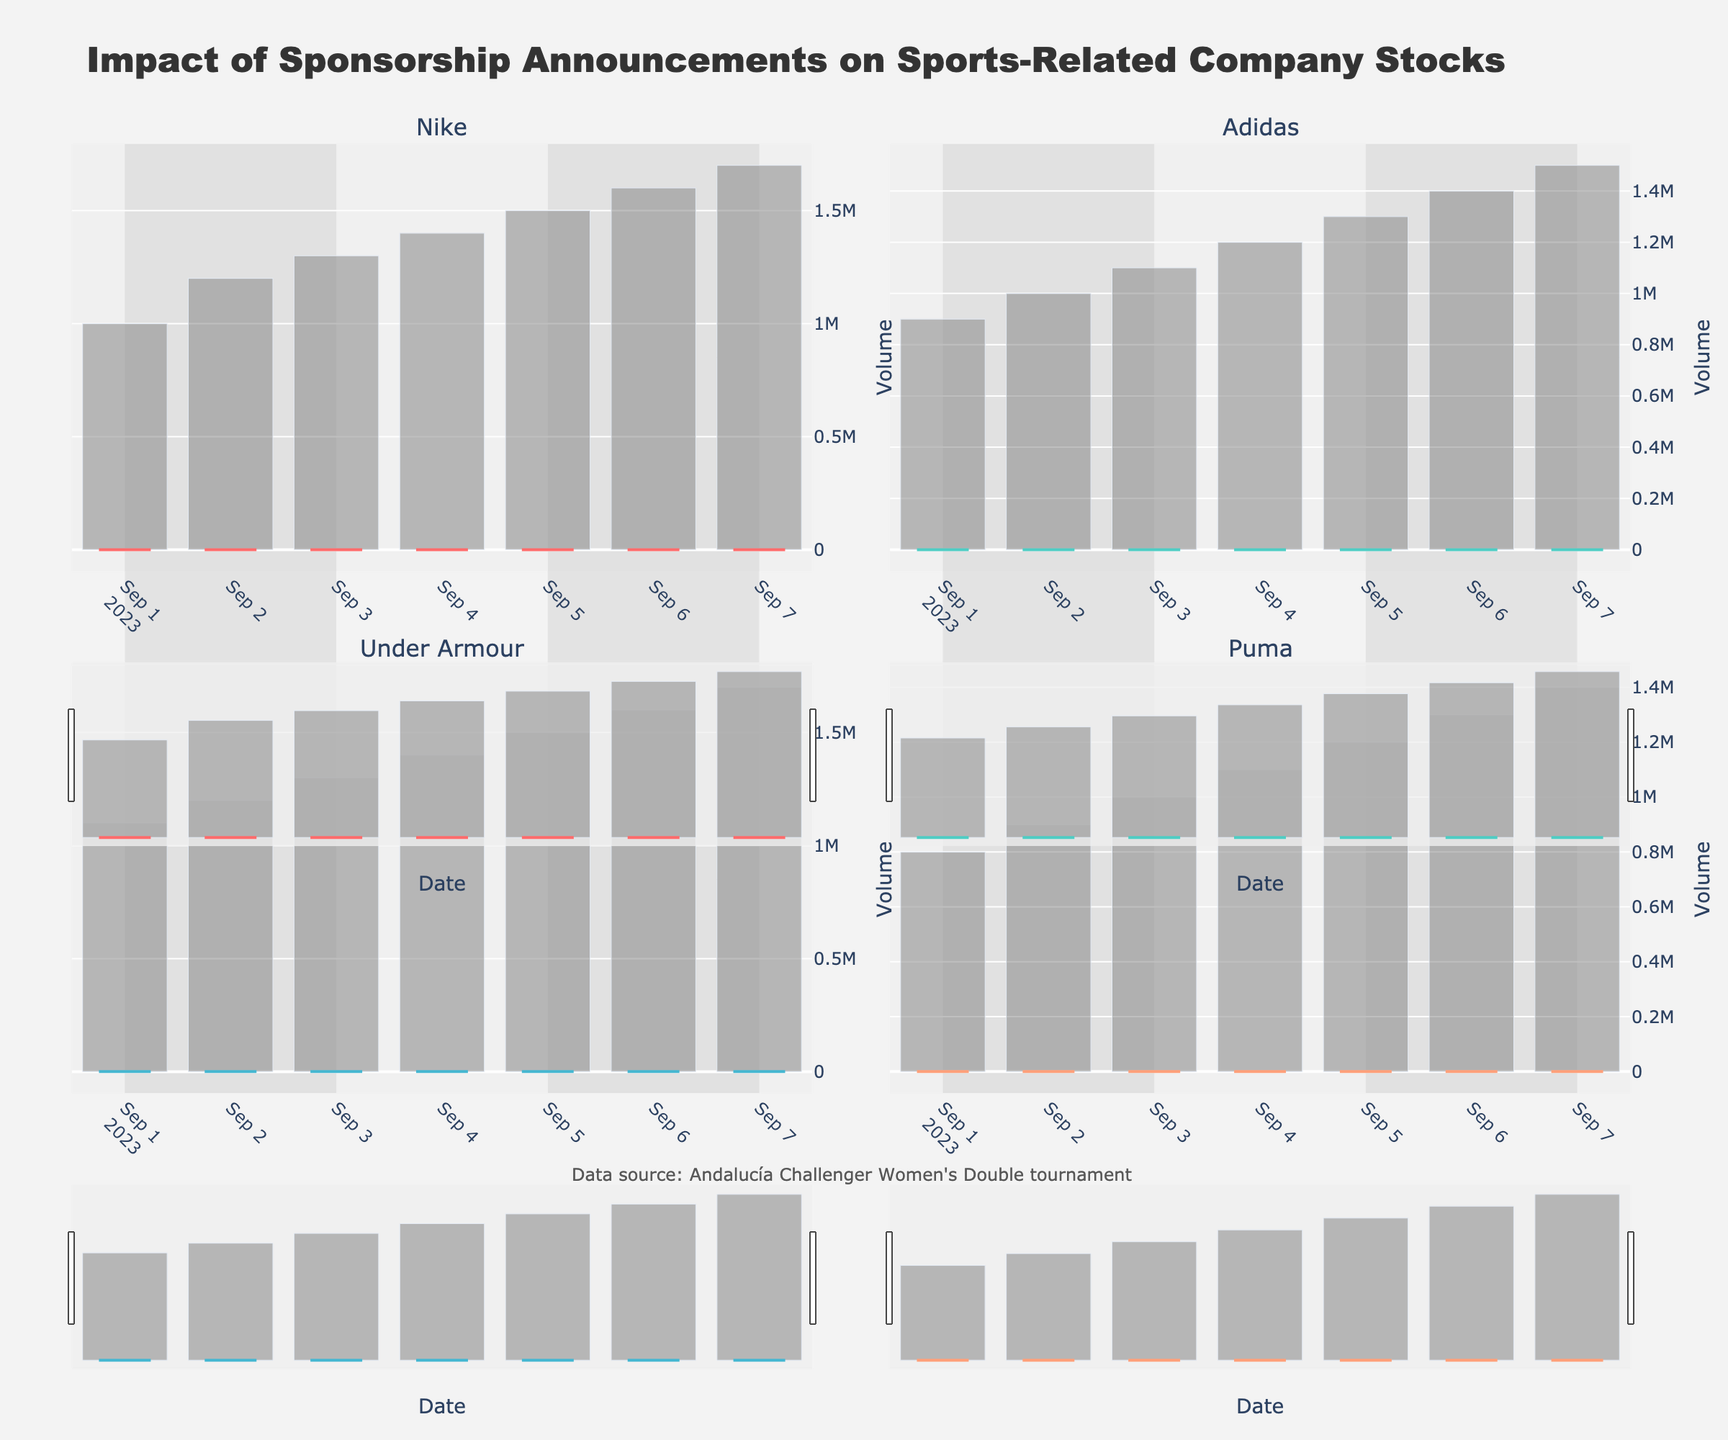Which company showed the largest increase in their stock price from the first day to the last day? For each company, subtract the opening price on September 1st from the closing price on September 7th. Nike: 161.00 - 150.00 = 11.00, Adidas: 114.00 - 100.00 = 14.00, Under Armour: 215.00 - 200.00 = 15.00, Puma: 63.50 - 50.00 = 13.50. The largest increase is for Under Armour, with an increase of 15.00.
Answer: Under Armour What was the stock price range (difference between high and low) for Nike on September 6th? Look at the high and low prices for Nike on September 6th. The high was 160.00 and the low was 157.00. Subtract the low price from the high price: 160.00 - 157.00 = 3.00.
Answer: 3.00 How did the volume change for Adidas from the day before the official sponsorship announcement to the day of the announcement? Compare the volume on September 3rd and September 4th for Adidas. On September 3rd, the volume was 1,100,000, and on September 4th, it was 1,200,000. Subtract the volume on September 3rd from the volume on September 4th: 1,200,000 - 1,100,000 = 100,000.
Answer: Increased by 100,000 Which company had the highest closing price on the day of the official sponsorship announcement? Look at the closing prices on September 4th for all companies. Nike: 155.50, Adidas: 106.50, Under Armour: 208.50, Puma: 56.50. The highest closing price was for Under Armour, at 208.50.
Answer: Under Armour What was the percentage increase in Nike's volume from the first day to the last day? Compare the volume on September 1st and September 7th for Nike. Volume on September 1st: 1,000,000; Volume on September 7th: 1,700,000. Calculate the percentage increase: ((1,700,000 - 1,000,000) / 1,000,000) * 100 = 70%.
Answer: 70% Considering the candlestick colors, did Puma's stock close higher or lower than it opened on September 5th? Look for the candlestick color for Puma on September 5th. It is a light color, indicating an increase. The opening price was 56.50, and the closing price was 58.50, meaning the stock closed higher than it opened.
Answer: Closed higher Which company had the highest volume on September 7th? Compare the volumes on September 7th for all companies. Nike: 1,700,000; Adidas: 1,500,000; Under Armour: 1,700,000; Puma: 1,400,000. The highest volumes are for Nike and Under Armour, both at 1,700,000.
Answer: Tie between Nike and Under Armour How did the stock prices of Nike and Under Armour compare on September 3rd? Compare the closing prices for Nike (154.50) and Under Armour (206.00) on September 3rd. Under Armour's closing price is higher than Nike's.
Answer: Under Armour's stock was higher Which company’s stock showed the most consistent increase in closing prices post the sponsorship announcement? Examine the closing prices post the announcement for each company: Nike: 157.50, 159.00, 161.00; Adidas: 108.50, 111.00, 114.00; Under Armour: 210.00, 212.50, 215.00; Puma: 58.50, 61.00, 63.50. Each company shows an increasing trend, but the most consistently increasing one can be observed by smallest differences.
Answer: Consistently increasing What is the closing price trend of Puma from September 5th to September 7th? Examine the closing prices of Puma from September 5th (58.50), September 6th (61.00), and September 7th (63.50). The closing prices show an increasing trend.
Answer: Increasing trend 